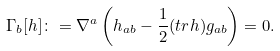Convert formula to latex. <formula><loc_0><loc_0><loc_500><loc_500>\Gamma _ { b } [ h ] \colon = \nabla ^ { a } \left ( h _ { a b } - \frac { 1 } { 2 } ( { t r } h ) g _ { a b } \right ) = 0 .</formula> 